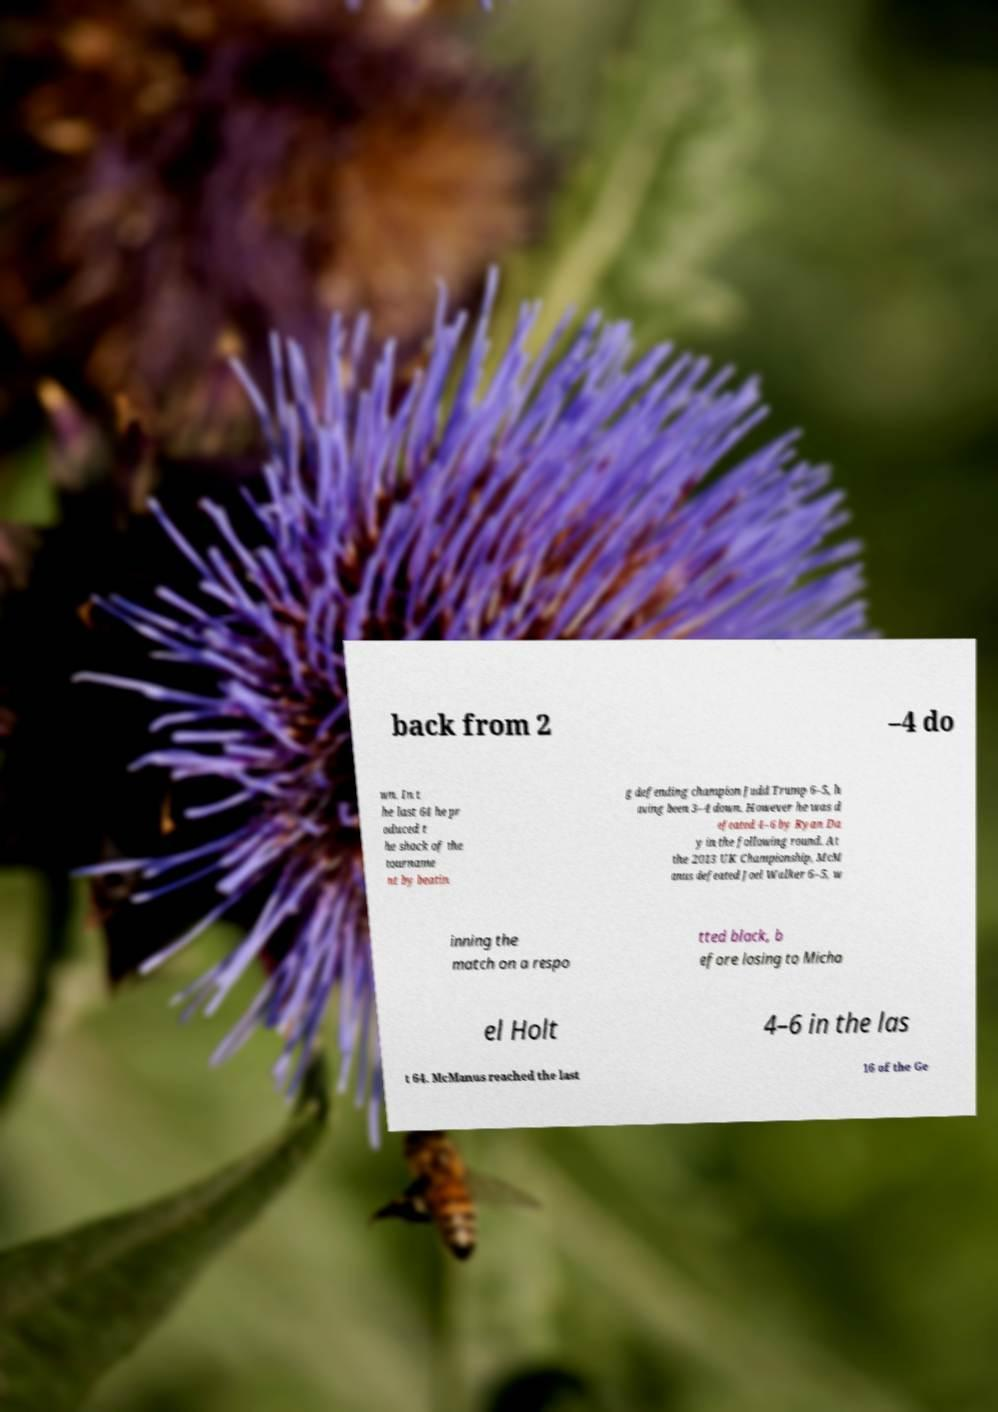Can you read and provide the text displayed in the image?This photo seems to have some interesting text. Can you extract and type it out for me? back from 2 –4 do wn. In t he last 64 he pr oduced t he shock of the tourname nt by beatin g defending champion Judd Trump 6–5, h aving been 3–4 down. However he was d efeated 4–6 by Ryan Da y in the following round. At the 2013 UK Championship, McM anus defeated Joel Walker 6–5, w inning the match on a respo tted black, b efore losing to Micha el Holt 4–6 in the las t 64. McManus reached the last 16 of the Ge 